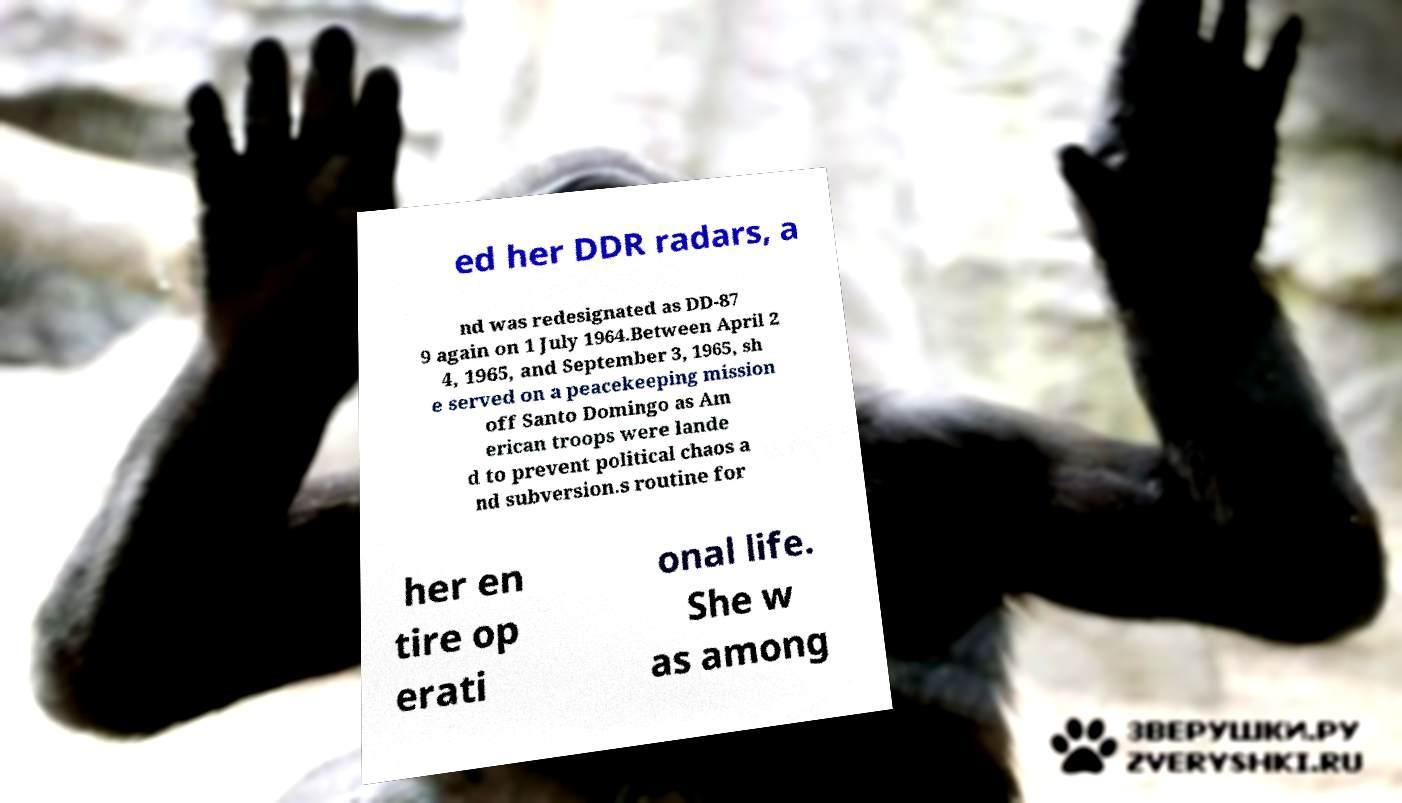Can you read and provide the text displayed in the image?This photo seems to have some interesting text. Can you extract and type it out for me? ed her DDR radars, a nd was redesignated as DD-87 9 again on 1 July 1964.Between April 2 4, 1965, and September 3, 1965, sh e served on a peacekeeping mission off Santo Domingo as Am erican troops were lande d to prevent political chaos a nd subversion.s routine for her en tire op erati onal life. She w as among 